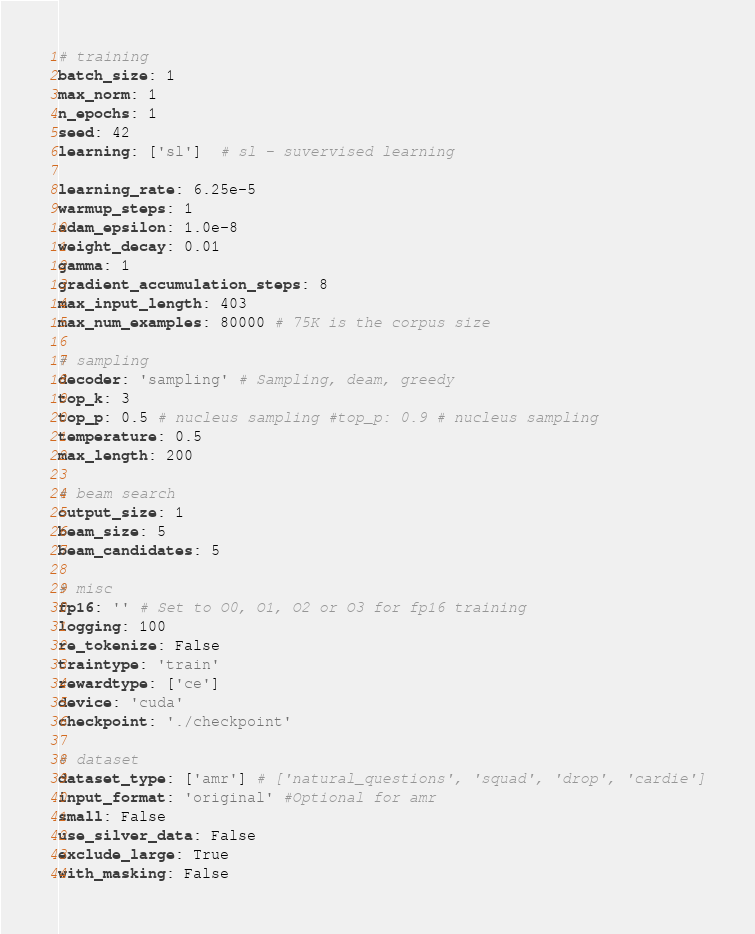<code> <loc_0><loc_0><loc_500><loc_500><_YAML_># training
batch_size: 1
max_norm: 1
n_epochs: 1
seed: 42
learning: ['sl']  # sl - suvervised learning

learning_rate: 6.25e-5
warmup_steps: 1
adam_epsilon: 1.0e-8
weight_decay: 0.01
gamma: 1
gradient_accumulation_steps: 8
max_input_length: 403
max_num_examples: 80000 # 75K is the corpus size

# sampling
decoder: 'sampling' # Sampling, deam, greedy
top_k: 3
top_p: 0.5 # nucleus sampling #top_p: 0.9 # nucleus sampling
temperature: 0.5 
max_length: 200

# beam search
output_size: 1
beam_size: 5
beam_candidates: 5

# misc
fp16: '' # Set to O0, O1, O2 or O3 for fp16 training
logging: 100
re_tokenize: False
traintype: 'train'
rewardtype: ['ce']
device: 'cuda'
checkpoint: './checkpoint'
    
# dataset
dataset_type: ['amr'] # ['natural_questions', 'squad', 'drop', 'cardie']
input_format: 'original' #Optional for amr
small: False
use_silver_data: False
exclude_large: True
with_masking: False
</code> 